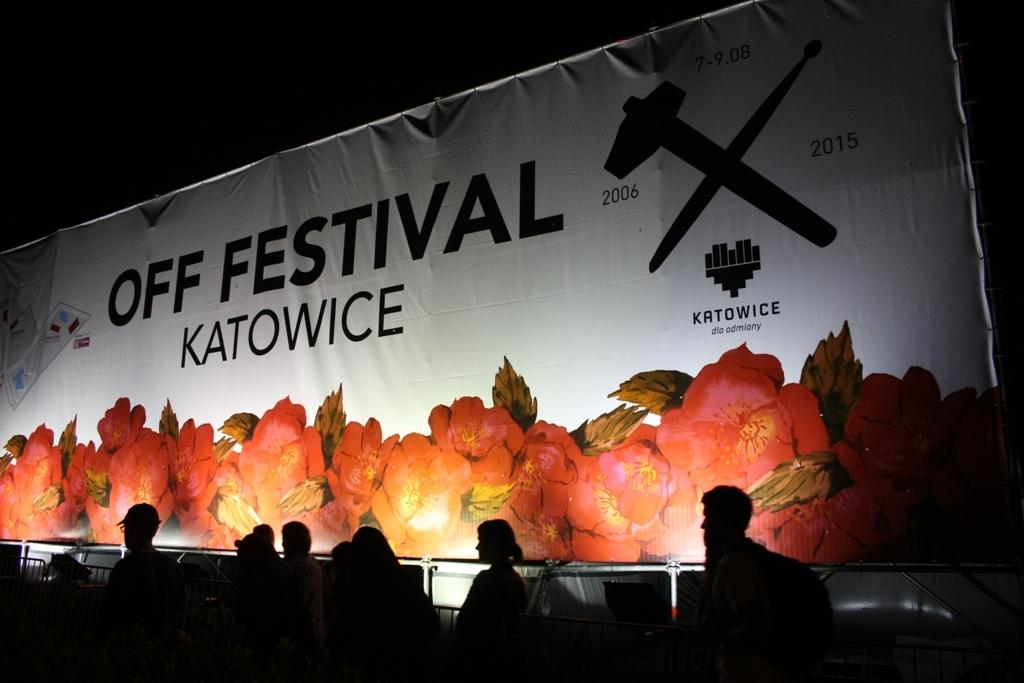Who or what is present in the image? There are people in the image. What can be seen in the middle of the image? There is a banner in the middle of the image. What type of government is depicted on the kitten in the image? There is no kitten present in the image, and therefore no government can be depicted on it. Is there any poison visible in the image? There is no mention of poison in the provided facts, and therefore it cannot be determined if any is present in the image. 